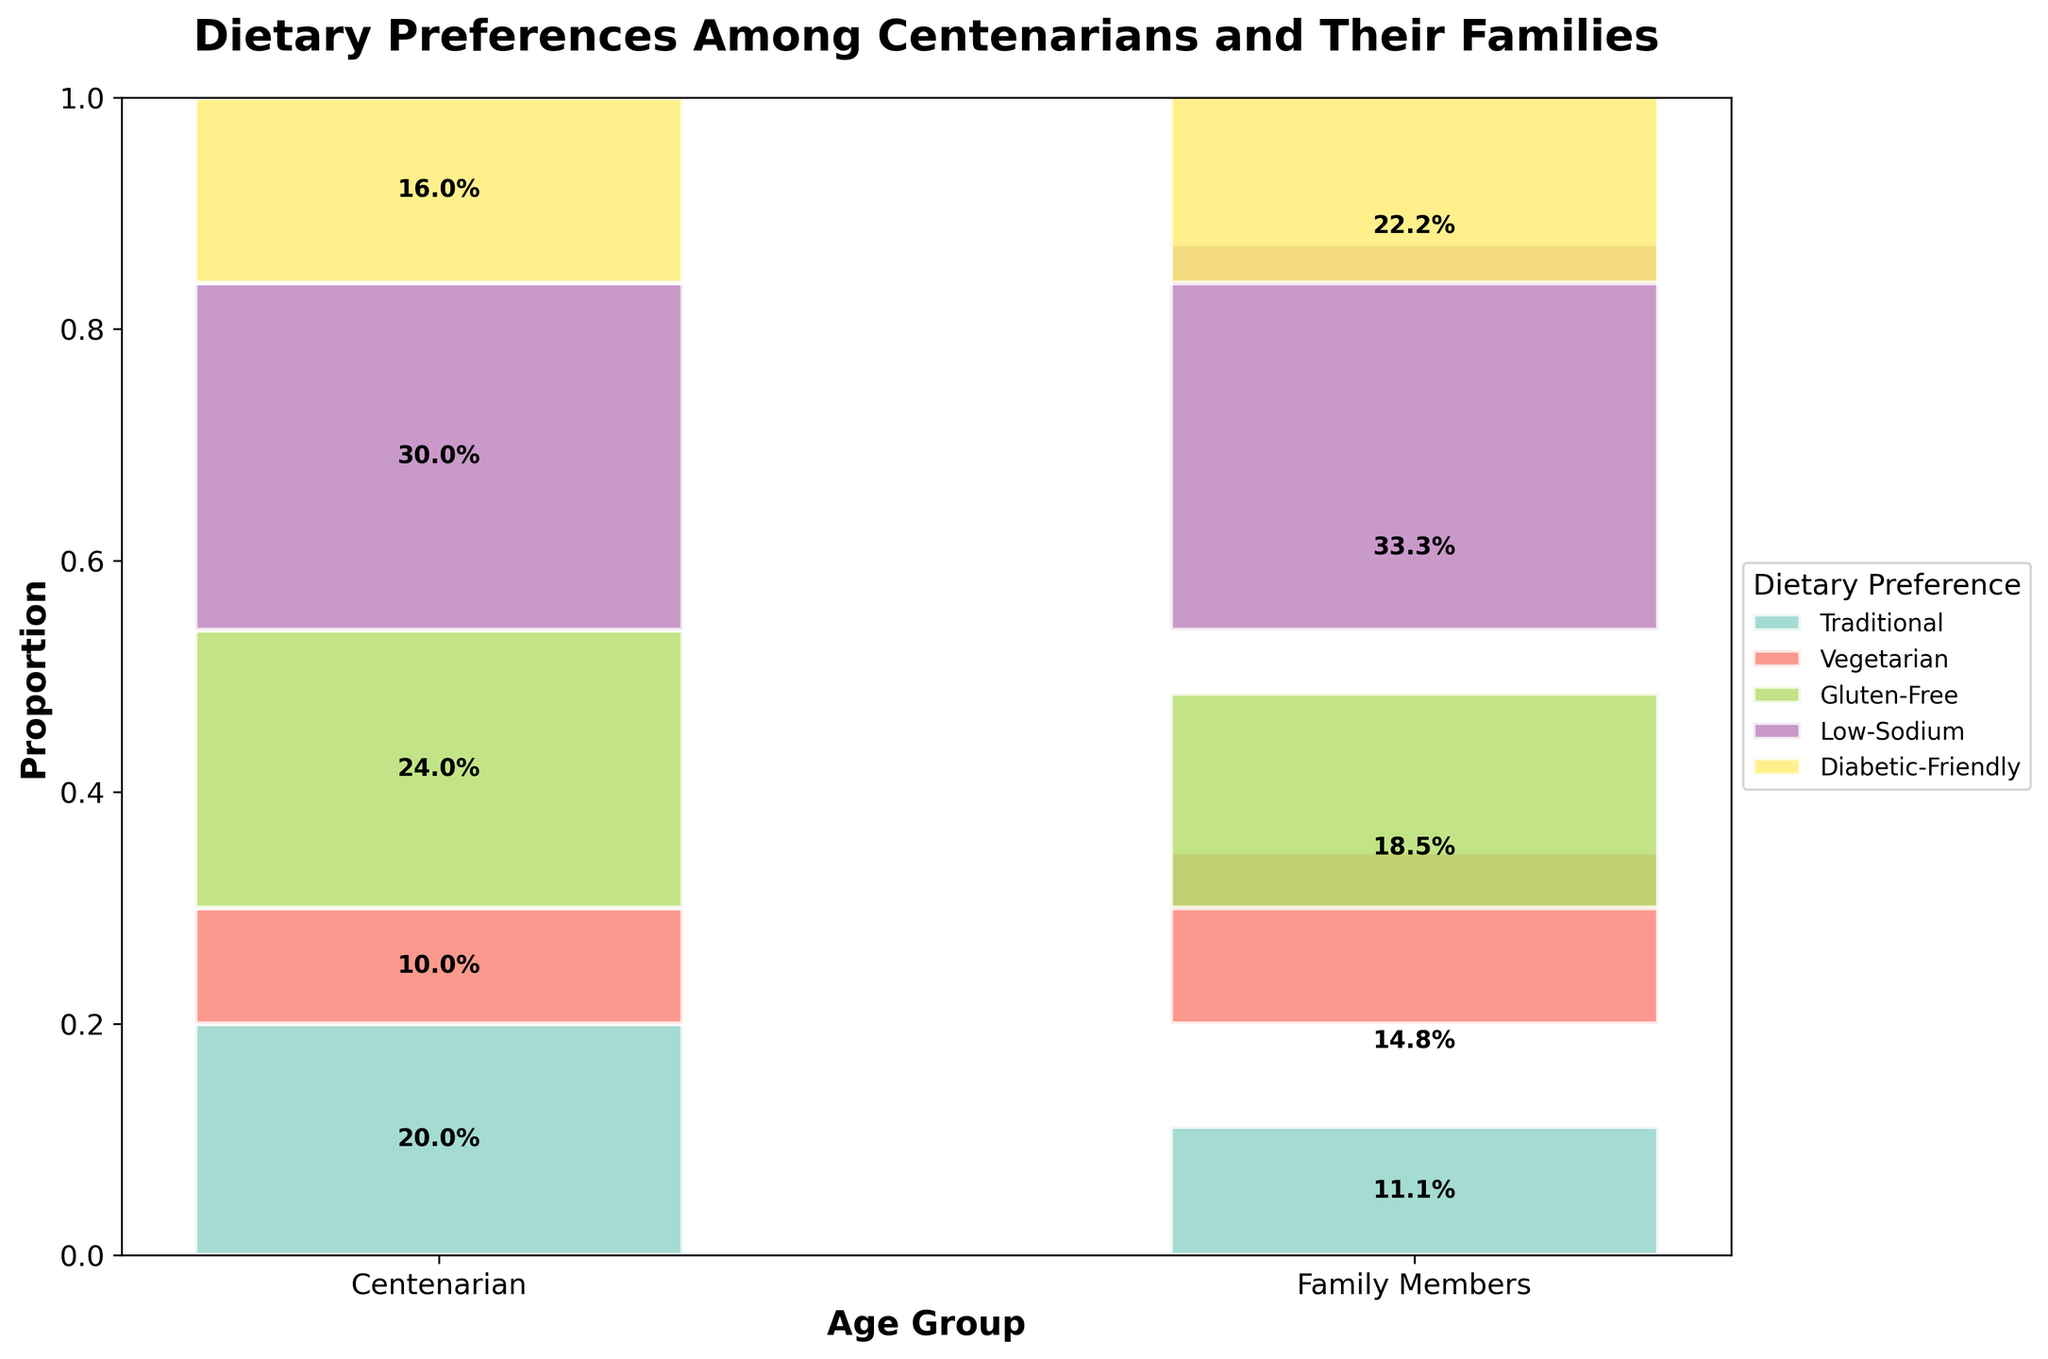What is the title of the plot? The title is at the top of the plot, usually in larger and bold font compared to the rest of the text.
Answer: Dietary Preferences Among Centenarians and Their Families Which age group prefers traditional dietary options the most? From the plot, we can see which age group has the highest proportion of the 'Traditional' dietary preference in terms of bar height and label percentage.
Answer: Family Members How many dietary preferences are represented in the figure? By counting the distinct segments (colors) in each bar corresponding to different dietary preferences.
Answer: 5 Which dietary preference has the smallest proportion within the Family Members age group? By looking at the bar corresponding to 'Family Members' and identifying the smallest segment.
Answer: Diabetic-Friendly What is the combined proportion of 'Vegetarian' and 'Gluten-Free' preferences among Centenarians? Adding the proportions of the 'Vegetarian' and 'Gluten-Free' segments within the 'Centenarian' bar.
Answer: 8 + 5 = 13, and thus 13/50 = 26% Which age group has a higher preference for Diabetic-Friendly options? Comparing the proportions of 'Diabetic-Friendly' segments between the Centenarian and Family Members bars.
Answer: Centenarian What is the difference in preference for Low-Sodium dietary options between Centenarians and Family Members? Subtracting the proportion of the 'Low-Sodium' segment in the 'Family Members' from that in the 'Centenarians'.
Answer: 12 - 25 = -13, and thus 25% - 12% = 13% How does the proportion of Vegetarian preference among centenarians compare to that among their family members? Comparing the height of the 'Vegetarian' segment in the Centenarian bar to that in the Family Members bar.
Answer: Family Members have a higher proportion What is the total number of Centenarians sampled for this survey? Summing up the counts provided for all dietary preferences specifically for the Centenarian age group.
Answer: 50 Is there a dietary preference that shows almost equal proportions between the two age groups? Checking if any segment has nearly the same height or percentage across both age groups.
Answer: Low-Sodium 